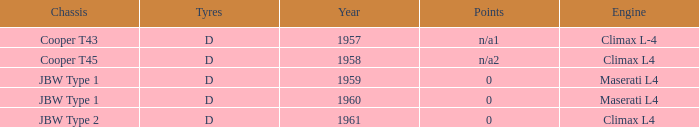What engine was for the vehicle with a cooper t43 chassis? Climax L-4. 